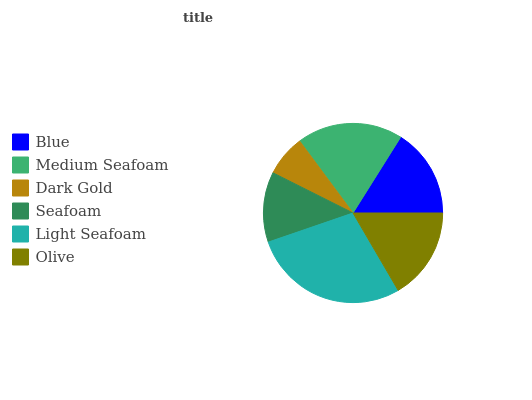Is Dark Gold the minimum?
Answer yes or no. Yes. Is Light Seafoam the maximum?
Answer yes or no. Yes. Is Medium Seafoam the minimum?
Answer yes or no. No. Is Medium Seafoam the maximum?
Answer yes or no. No. Is Medium Seafoam greater than Blue?
Answer yes or no. Yes. Is Blue less than Medium Seafoam?
Answer yes or no. Yes. Is Blue greater than Medium Seafoam?
Answer yes or no. No. Is Medium Seafoam less than Blue?
Answer yes or no. No. Is Olive the high median?
Answer yes or no. Yes. Is Blue the low median?
Answer yes or no. Yes. Is Light Seafoam the high median?
Answer yes or no. No. Is Medium Seafoam the low median?
Answer yes or no. No. 